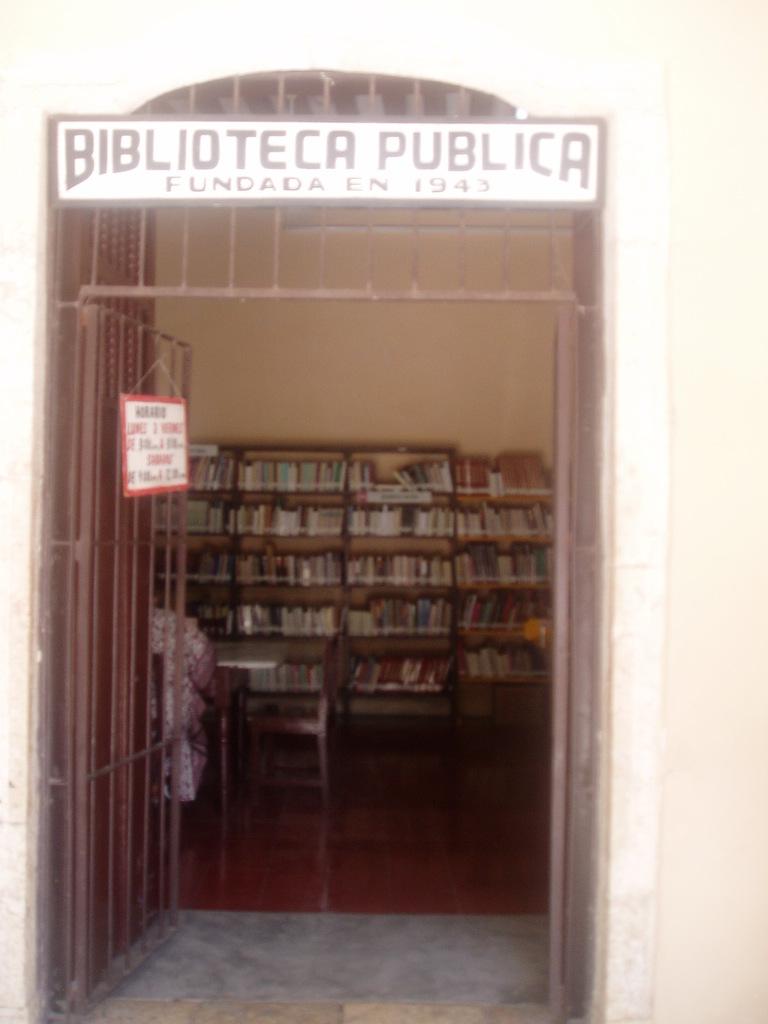What is the name of this establishment?
Give a very brief answer. Biblioteca publica. 